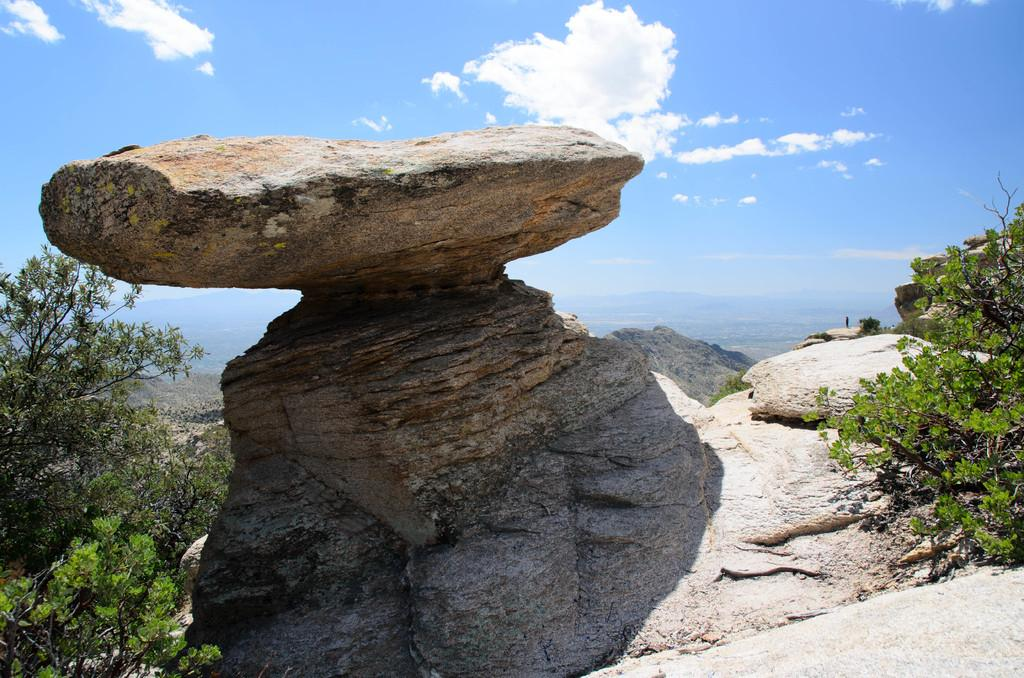What type of natural elements can be seen in the image? There are rocks and trees in the image. Can you describe the rocks in the image? The rocks in the image are visible and part of the natural landscape. What type of vegetation is present in the image? There are trees in the image, which are a type of vegetation. What type of amusement can be seen in the image? There is no amusement present in the image; it features rocks and trees. What trick is being performed with the rocks in the image? There is no trick being performed with the rocks in the image; they are simply part of the natural landscape. 